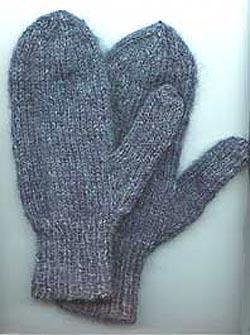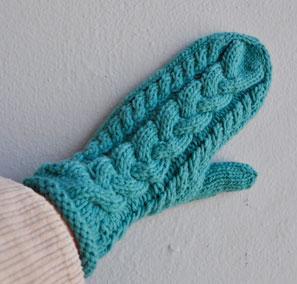The first image is the image on the left, the second image is the image on the right. Evaluate the accuracy of this statement regarding the images: "And at least one image there is somebody wearing mittens where the Fingers are not visible". Is it true? Answer yes or no. Yes. The first image is the image on the left, the second image is the image on the right. Assess this claim about the two images: "At least one mitten is being worn and at least one mitten is not.". Correct or not? Answer yes or no. Yes. 